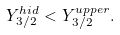Convert formula to latex. <formula><loc_0><loc_0><loc_500><loc_500>Y _ { 3 / 2 } ^ { h i d } < Y _ { 3 / 2 } ^ { u p p e r } .</formula> 